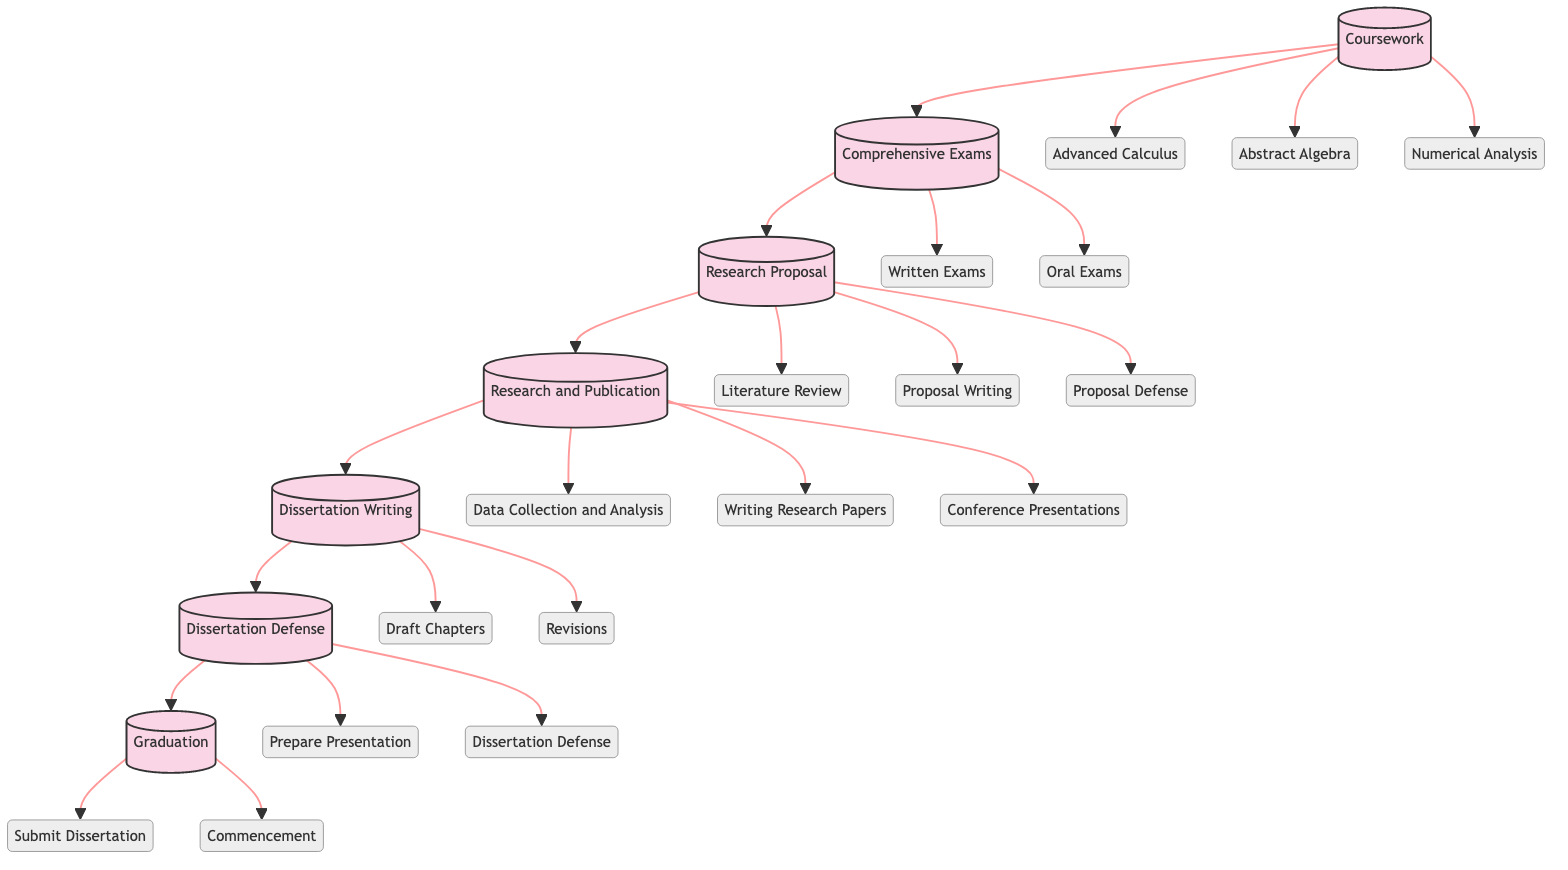What are the three courses required in the Coursework milestone? The Coursework milestone lists three required courses: Advanced Calculus, Abstract Algebra, and Numerical Analysis. These are all actions branching from the Coursework milestone node, indicating they must be completed.
Answer: Advanced Calculus, Abstract Algebra, Numerical Analysis How many actions are there under the Research Proposal milestone? The Research Proposal milestone contains three actions: Literature Review, Proposal Writing, and Proposal Defense, which are directly connected to this milestone node. Counting these gives us three actions.
Answer: 3 What is the order of milestones from Coursework to Graduation? The milestones are ordered sequentially as follows: Coursework → Comprehensive Exams → Research Proposal → Research and Publication → Dissertation Writing → Dissertation Defense → Graduation. This order is shown by the directed connections in the diagram that lead from one milestone to the next.
Answer: Coursework, Comprehensive Exams, Research Proposal, Research and Publication, Dissertation Writing, Dissertation Defense, Graduation How many edges connect to the Dissertation Defense milestone? The Dissertation Defense milestone connects to three items: the Dissertation Writing milestone, and two actions (Prepare Presentation and Dissertation Defense). Therefore, there are four edges in total connected to it. Each connection directly leads from the Dissertation Defense node to these items, indicating the flow of the process.
Answer: 4 What is the last action in the flow after Dissertation Defense? The last action after the Dissertation Defense is Commencement, which connects to the Graduation milestone indicating participation in graduation ceremonies after all academic requirements are completed. This is the endpoint in the directed graph.
Answer: Commencement 